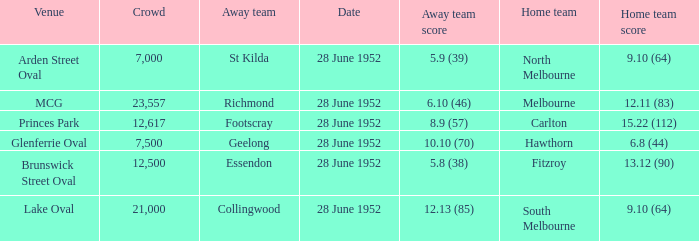What is the away team when north melbourne is at home? St Kilda. 